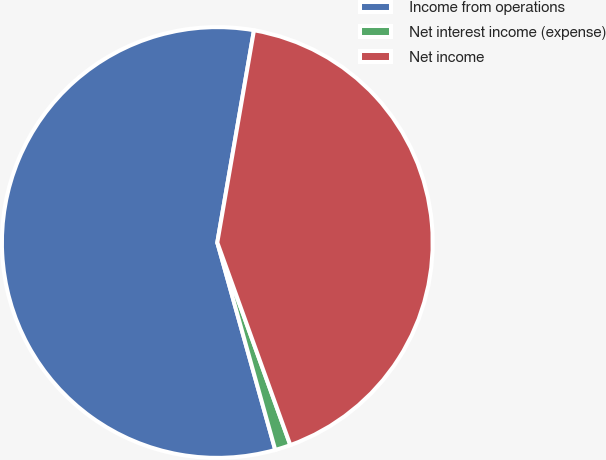Convert chart. <chart><loc_0><loc_0><loc_500><loc_500><pie_chart><fcel>Income from operations<fcel>Net interest income (expense)<fcel>Net income<nl><fcel>57.06%<fcel>1.17%<fcel>41.77%<nl></chart> 